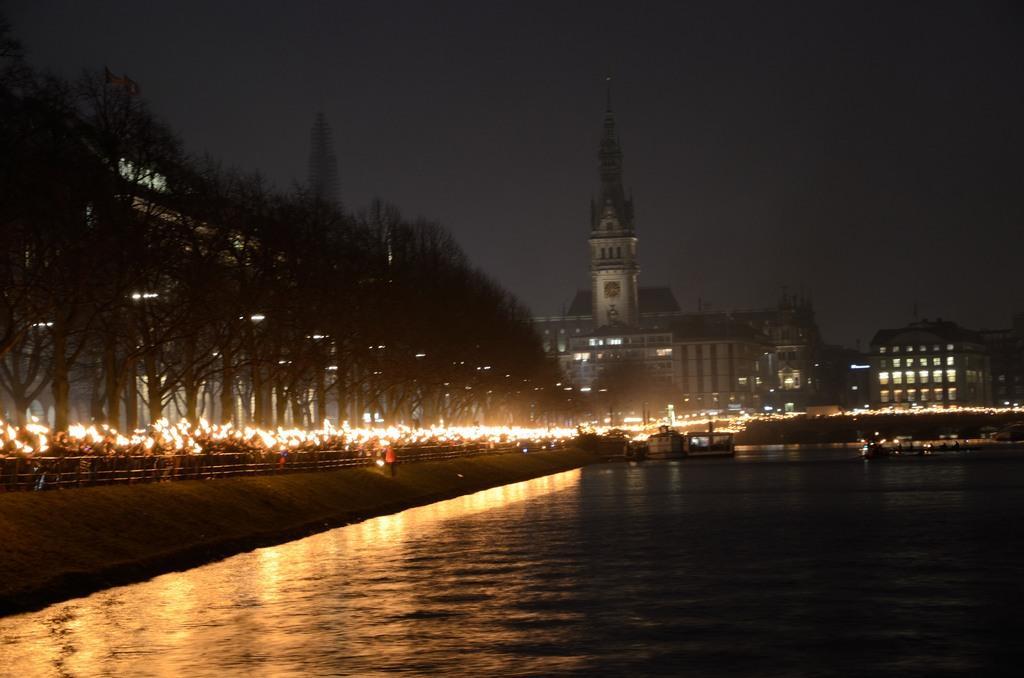Describe this image in one or two sentences. Here in this picture on the right side we can see water present all over there and we can see a couple of boats in it and on the left side we can see number of people standing on the road, as they are carrying something, which is lightened up and we can see railing beside them all over there and we can also see trees present over there and we can see building towers and buildings present over there. 